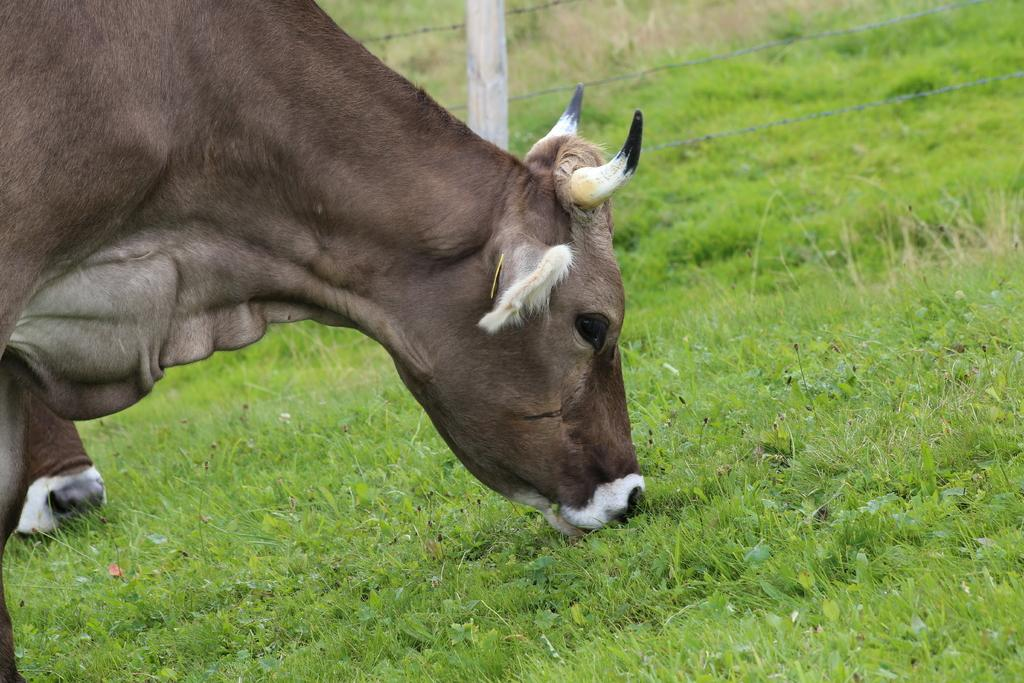What type of living organisms can be seen in the image? There are animals in the image. What are the animals doing in the image? The animals are eating grass. What is the purpose of the fencing in the image? The fencing in the image may be used to contain or separate the animals. What type of pancake can be seen in the image? There is no pancake present in the image. 